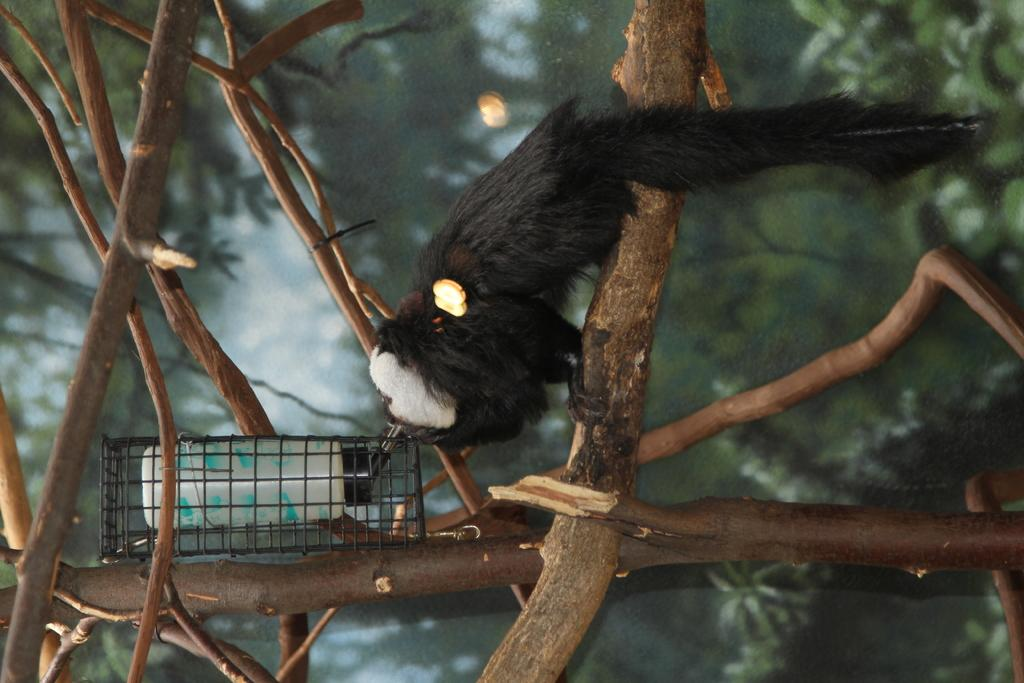What is inside the cage in the image? There is a bottle inside a cage in the image. What can be seen in the background of the image? Trees and branches are visible in the background of the image. Is there any living creature present in the image? Yes, there is an animal in the background of the image. What size of bucket is used to collect the animal's fear in the image? There is no bucket or fear present in the image. The image only shows a bottle inside a cage and an animal in the background. 